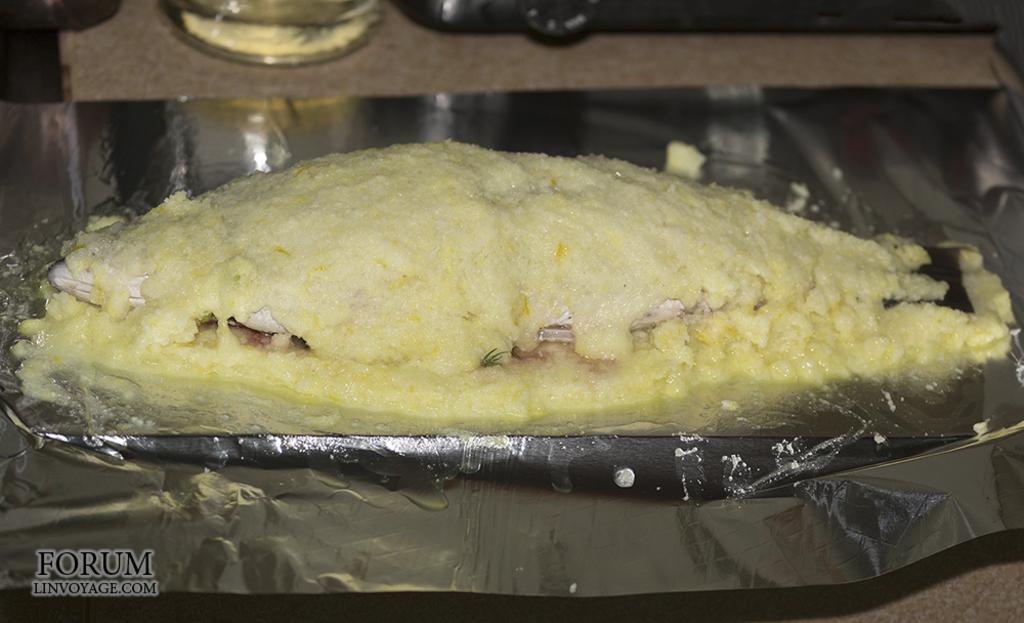Describe this image in one or two sentences. In this picture I can see the aluminium foil and on it I can see a fish which is covered with yellow color thing. On the bottom of this picture I can see the watermark. 